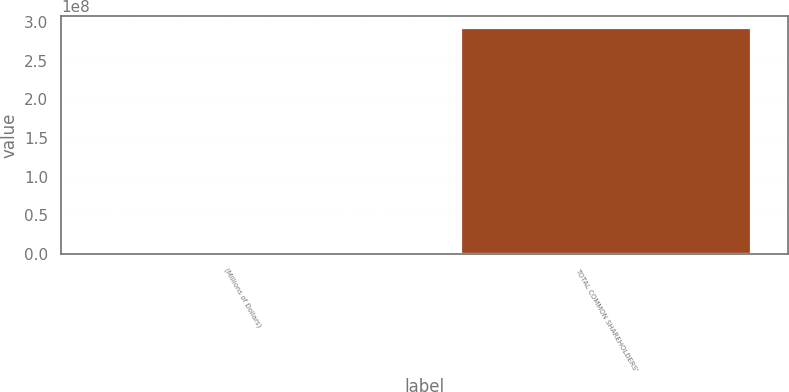Convert chart. <chart><loc_0><loc_0><loc_500><loc_500><bar_chart><fcel>(Millions of Dollars)<fcel>TOTAL COMMON SHAREHOLDERS'<nl><fcel>2013<fcel>2.92872e+08<nl></chart> 